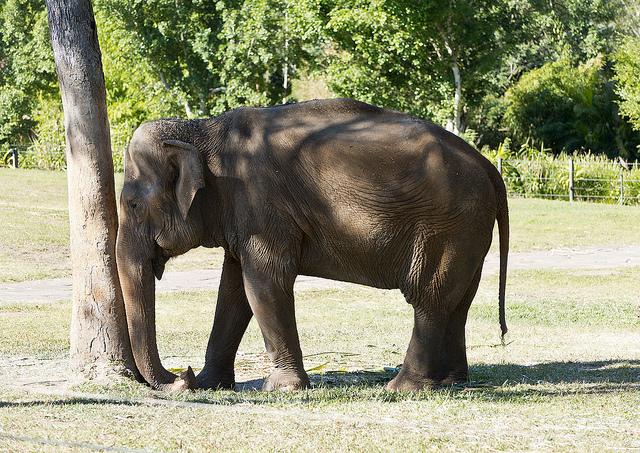Is the elephant's trunk touching the ground?
Quick response, please. Yes. Is the elephant playing?
Answer briefly. No. Is the elephant scratching it's nose?
Short answer required. Yes. Is this an adult Elephant?
Keep it brief. Yes. Does this elephant have water on him?
Concise answer only. No. Is the grass green?
Quick response, please. Yes. 